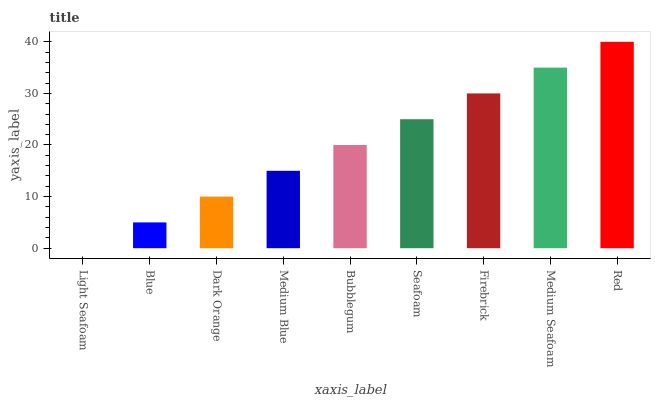Is Light Seafoam the minimum?
Answer yes or no. Yes. Is Red the maximum?
Answer yes or no. Yes. Is Blue the minimum?
Answer yes or no. No. Is Blue the maximum?
Answer yes or no. No. Is Blue greater than Light Seafoam?
Answer yes or no. Yes. Is Light Seafoam less than Blue?
Answer yes or no. Yes. Is Light Seafoam greater than Blue?
Answer yes or no. No. Is Blue less than Light Seafoam?
Answer yes or no. No. Is Bubblegum the high median?
Answer yes or no. Yes. Is Bubblegum the low median?
Answer yes or no. Yes. Is Red the high median?
Answer yes or no. No. Is Dark Orange the low median?
Answer yes or no. No. 